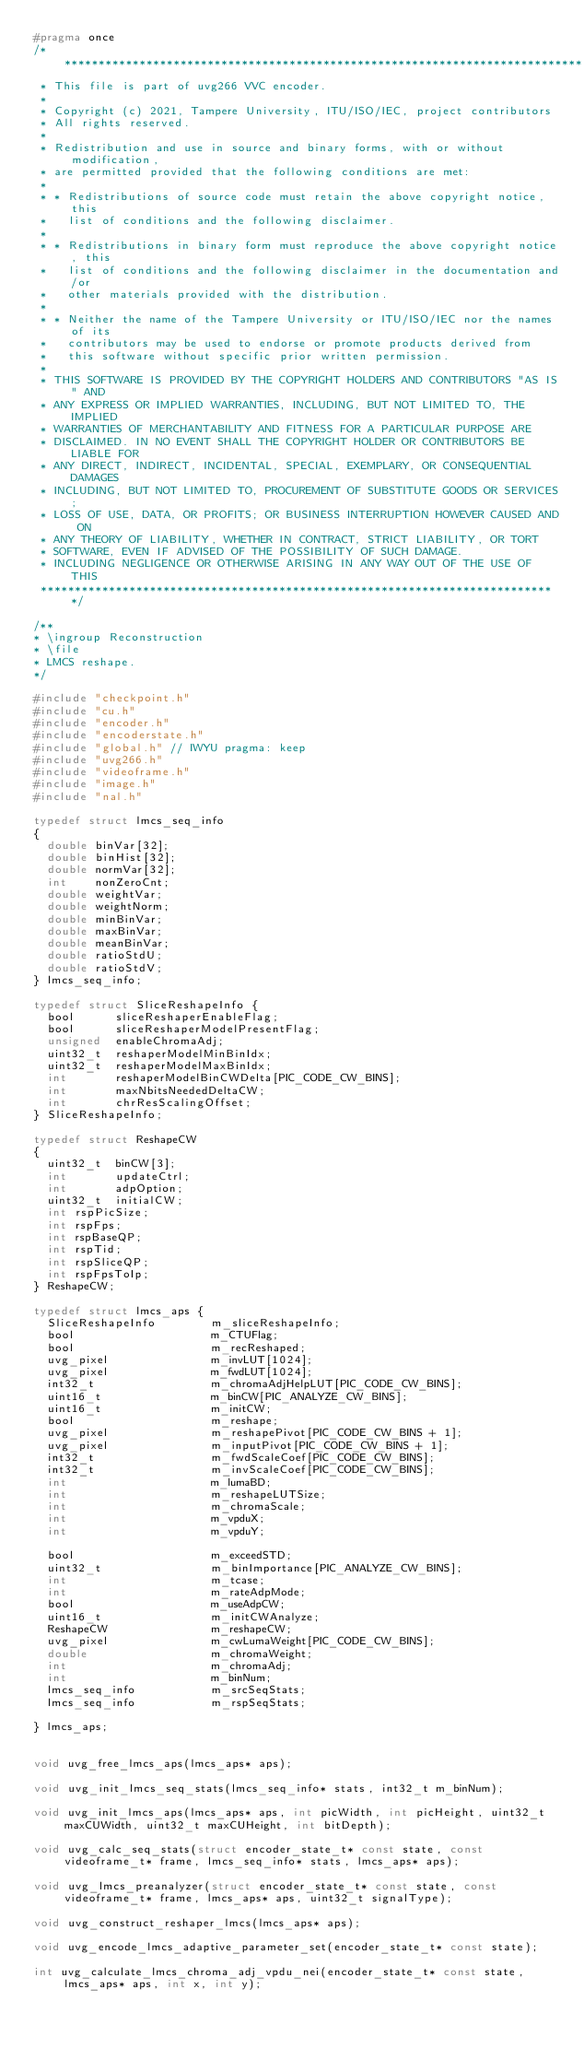Convert code to text. <code><loc_0><loc_0><loc_500><loc_500><_C_>#pragma once
/*****************************************************************************
 * This file is part of uvg266 VVC encoder.
 *
 * Copyright (c) 2021, Tampere University, ITU/ISO/IEC, project contributors
 * All rights reserved.
 *
 * Redistribution and use in source and binary forms, with or without modification,
 * are permitted provided that the following conditions are met:
 *
 * * Redistributions of source code must retain the above copyright notice, this
 *   list of conditions and the following disclaimer.
 *
 * * Redistributions in binary form must reproduce the above copyright notice, this
 *   list of conditions and the following disclaimer in the documentation and/or
 *   other materials provided with the distribution.
 *
 * * Neither the name of the Tampere University or ITU/ISO/IEC nor the names of its
 *   contributors may be used to endorse or promote products derived from
 *   this software without specific prior written permission.
 *
 * THIS SOFTWARE IS PROVIDED BY THE COPYRIGHT HOLDERS AND CONTRIBUTORS "AS IS" AND
 * ANY EXPRESS OR IMPLIED WARRANTIES, INCLUDING, BUT NOT LIMITED TO, THE IMPLIED
 * WARRANTIES OF MERCHANTABILITY AND FITNESS FOR A PARTICULAR PURPOSE ARE
 * DISCLAIMED. IN NO EVENT SHALL THE COPYRIGHT HOLDER OR CONTRIBUTORS BE LIABLE FOR
 * ANY DIRECT, INDIRECT, INCIDENTAL, SPECIAL, EXEMPLARY, OR CONSEQUENTIAL DAMAGES
 * INCLUDING, BUT NOT LIMITED TO, PROCUREMENT OF SUBSTITUTE GOODS OR SERVICES;
 * LOSS OF USE, DATA, OR PROFITS; OR BUSINESS INTERRUPTION HOWEVER CAUSED AND ON
 * ANY THEORY OF LIABILITY, WHETHER IN CONTRACT, STRICT LIABILITY, OR TORT
 * SOFTWARE, EVEN IF ADVISED OF THE POSSIBILITY OF SUCH DAMAGE.
 * INCLUDING NEGLIGENCE OR OTHERWISE ARISING IN ANY WAY OUT OF THE USE OF THIS
 ****************************************************************************/

/**
* \ingroup Reconstruction
* \file
* LMCS reshape.
*/

#include "checkpoint.h"
#include "cu.h"
#include "encoder.h"
#include "encoderstate.h"
#include "global.h" // IWYU pragma: keep
#include "uvg266.h"
#include "videoframe.h"
#include "image.h"
#include "nal.h"

typedef struct lmcs_seq_info
{
  double binVar[32];
  double binHist[32];
  double normVar[32];
  int    nonZeroCnt;
  double weightVar;
  double weightNorm;
  double minBinVar;
  double maxBinVar;
  double meanBinVar;
  double ratioStdU;
  double ratioStdV;
} lmcs_seq_info;

typedef struct SliceReshapeInfo {
  bool      sliceReshaperEnableFlag;
  bool      sliceReshaperModelPresentFlag;
  unsigned  enableChromaAdj;
  uint32_t  reshaperModelMinBinIdx;
  uint32_t  reshaperModelMaxBinIdx;
  int       reshaperModelBinCWDelta[PIC_CODE_CW_BINS];
  int       maxNbitsNeededDeltaCW;
  int       chrResScalingOffset;
} SliceReshapeInfo;

typedef struct ReshapeCW
{
  uint32_t  binCW[3];
  int       updateCtrl;
  int       adpOption;
  uint32_t  initialCW;
  int rspPicSize;
  int rspFps;
  int rspBaseQP;
  int rspTid;
  int rspSliceQP;
  int rspFpsToIp;
} ReshapeCW;

typedef struct lmcs_aps {
  SliceReshapeInfo        m_sliceReshapeInfo;
  bool                    m_CTUFlag;
  bool                    m_recReshaped;
  uvg_pixel               m_invLUT[1024];
  uvg_pixel               m_fwdLUT[1024];
  int32_t                 m_chromaAdjHelpLUT[PIC_CODE_CW_BINS];
  uint16_t                m_binCW[PIC_ANALYZE_CW_BINS];
  uint16_t                m_initCW;
  bool                    m_reshape;
  uvg_pixel               m_reshapePivot[PIC_CODE_CW_BINS + 1];
  uvg_pixel               m_inputPivot[PIC_CODE_CW_BINS + 1];
  int32_t                 m_fwdScaleCoef[PIC_CODE_CW_BINS];
  int32_t                 m_invScaleCoef[PIC_CODE_CW_BINS];
  int                     m_lumaBD;
  int                     m_reshapeLUTSize;
  int                     m_chromaScale;
  int                     m_vpduX;
  int                     m_vpduY;

  bool                    m_exceedSTD;
  uint32_t                m_binImportance[PIC_ANALYZE_CW_BINS];
  int                     m_tcase;
  int                     m_rateAdpMode;
  bool                    m_useAdpCW;
  uint16_t                m_initCWAnalyze;
  ReshapeCW               m_reshapeCW;
  uvg_pixel               m_cwLumaWeight[PIC_CODE_CW_BINS];
  double                  m_chromaWeight;
  int                     m_chromaAdj;
  int                     m_binNum;
  lmcs_seq_info           m_srcSeqStats;
  lmcs_seq_info           m_rspSeqStats;

} lmcs_aps;


void uvg_free_lmcs_aps(lmcs_aps* aps);

void uvg_init_lmcs_seq_stats(lmcs_seq_info* stats, int32_t m_binNum);

void uvg_init_lmcs_aps(lmcs_aps* aps, int picWidth, int picHeight, uint32_t maxCUWidth, uint32_t maxCUHeight, int bitDepth);

void uvg_calc_seq_stats(struct encoder_state_t* const state, const videoframe_t* frame, lmcs_seq_info* stats, lmcs_aps* aps);

void uvg_lmcs_preanalyzer(struct encoder_state_t* const state, const videoframe_t* frame, lmcs_aps* aps, uint32_t signalType);

void uvg_construct_reshaper_lmcs(lmcs_aps* aps);

void uvg_encode_lmcs_adaptive_parameter_set(encoder_state_t* const state);

int uvg_calculate_lmcs_chroma_adj_vpdu_nei(encoder_state_t* const state, lmcs_aps* aps, int x, int y);</code> 